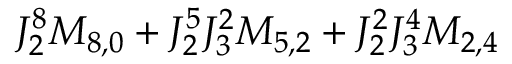<formula> <loc_0><loc_0><loc_500><loc_500>J _ { 2 } ^ { 8 } M _ { 8 , 0 } + J _ { 2 } ^ { 5 } J _ { 3 } ^ { 2 } M _ { 5 , 2 } + J _ { 2 } ^ { 2 } J _ { 3 } ^ { 4 } M _ { 2 , 4 }</formula> 